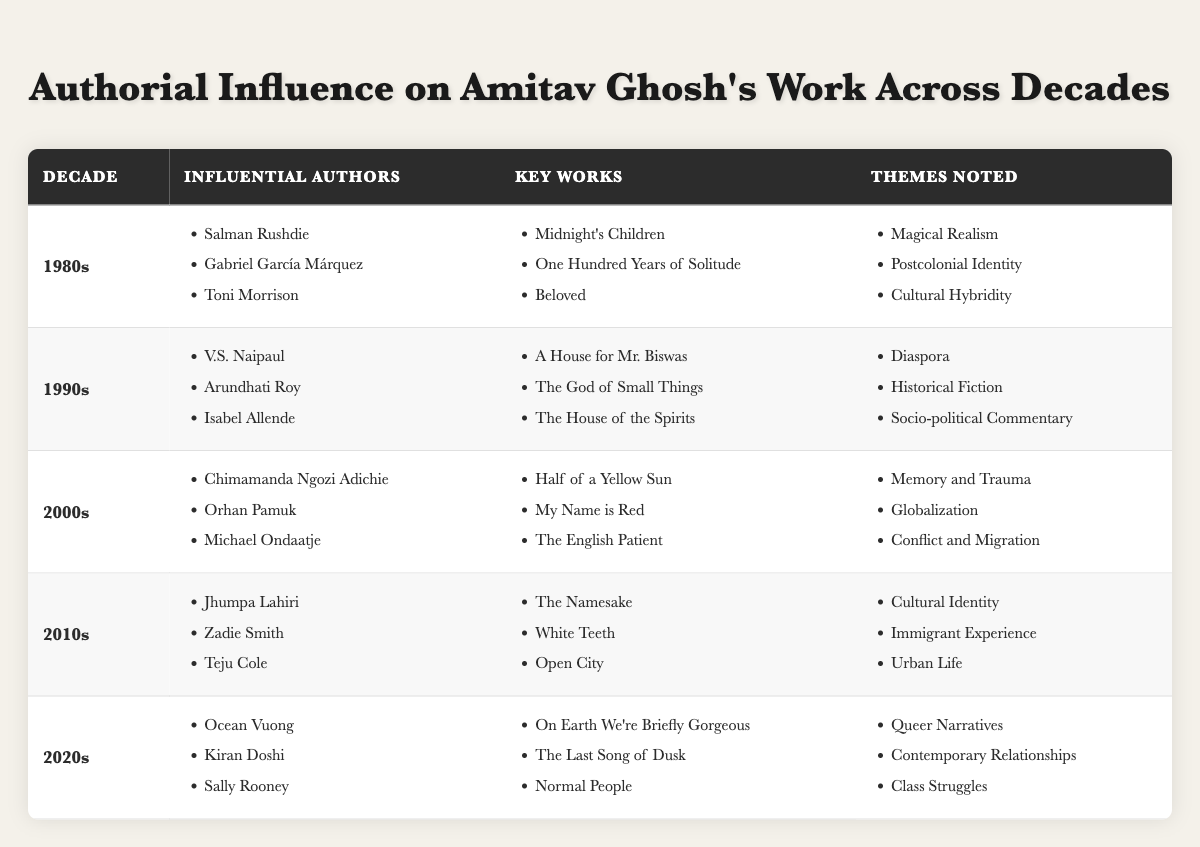What authors influenced Amitav Ghosh in the 1990s? The table indicates that the influential authors on Ghosh's work in the 1990s were V.S. Naipaul, Arundhati Roy, and Isabel Allende, as seen in the respective row for that decade.
Answer: V.S. Naipaul, Arundhati Roy, Isabel Allende What key work is associated with Salman Rushdie in the 1980s? Referring to the 1980s row in the table, the key work listed for Salman Rushdie is "Midnight's Children."
Answer: Midnight's Children Did the theme of "Postcolonial Identity" appear in the 2000s? The table shows that "Postcolonial Identity" is listed under the themes noted for the 1980s but not in the 2000s. Therefore, this theme did not appear in the 2000s.
Answer: No Which decade saw the emergence of "Queer Narratives" as a noted theme? By examining the table, "Queer Narratives" is noted as a theme in the 2020s, making it that decade where the theme emerged.
Answer: 2020s How many influential authors are listed for the 2010s? The 2010s row displays three influential authors: Jhumpa Lahiri, Zadie Smith, and Teju Cole. Therefore, there are three authors.
Answer: Three Which themes are noted for the 1990s? The table supports that the themes noted for the 1990s are "Diaspora," "Historical Fiction," and "Socio-political Commentary."
Answer: Diaspora, Historical Fiction, Socio-political Commentary Is "Half of a Yellow Sun" by Chimamanda Ngozi Adichie noted in the 1990s? The table specifies that "Half of a Yellow Sun," written by Chimamanda Ngozi Adichie, is listed as a key work in the 2000s, indicating it is not from the 1990s.
Answer: No What is the relationship between key works and their corresponding influential authors in the 2000s? The table shows that Chimamanda Ngozi Adichie, Orhan Pamuk, and Michael Ondaatje are influential authors linked with "Half of a Yellow Sun," "My Name is Red," and "The English Patient" in the 2000s, establishing a direct connection between these authors and their works.
Answer: Direct connection How does the influence of authors on Amitav Ghosh's work change from the 1980s to the 2010s? To understand the change, one should notice the shift in themes from "Magical Realism" and "Cultural Hybridity" in the 1980s to "Cultural Identity" and "Urban Life" in the 2010s, reflecting a broader engagement with different aspects of society over time.
Answer: Shift in societal themes What themes are associated with both the 2000s and the 2020s? By reviewing the themes mentioned in both decades, it is clear that there are no shared themes; the 2000s focus on "Memory and Trauma," "Globalization," and "Conflict and Migration," while the 2020s focus on "Queer Narratives," "Contemporary Relationships," and "Class Struggles."
Answer: No shared themes 